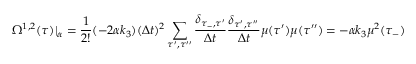Convert formula to latex. <formula><loc_0><loc_0><loc_500><loc_500>\Omega ^ { 1 , 2 } ( \tau ) | _ { \alpha } = \frac { 1 } { 2 ! } ( - 2 \alpha k _ { 3 } ) ( \Delta t ) ^ { 2 } \sum _ { \tau ^ { \prime } , \tau ^ { \prime \prime } } \frac { \delta _ { \tau _ { - } , \tau ^ { \prime } } } { \Delta t } \frac { \delta _ { \tau ^ { \prime } , \tau ^ { \prime \prime } } } { \Delta t } \mu ( \tau ^ { \prime } ) \mu ( \tau ^ { \prime \prime } ) = - \alpha k _ { 3 } \mu ^ { 2 } ( \tau _ { - } )</formula> 